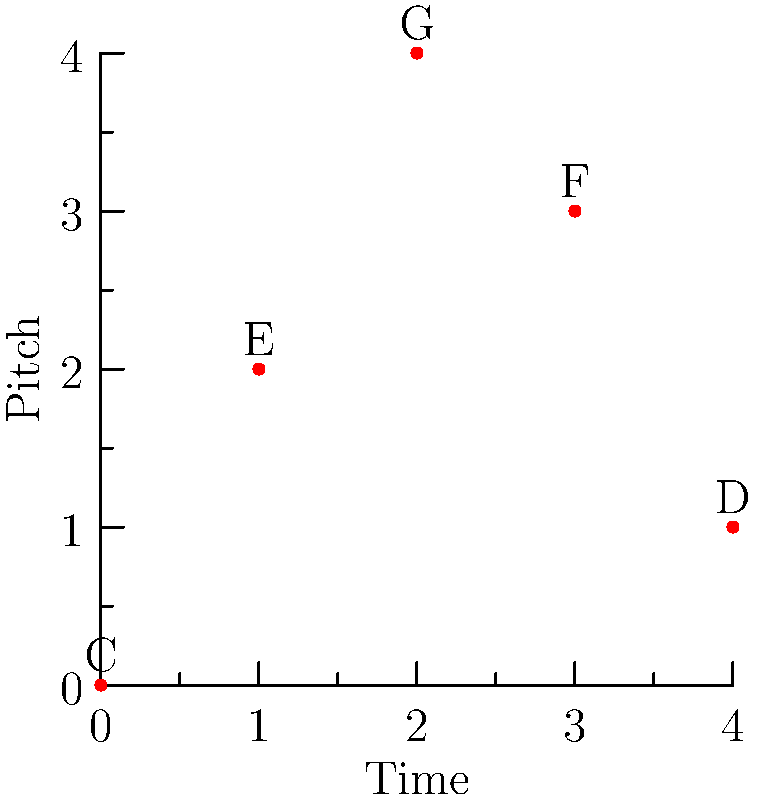As a singer-songwriter, you've composed a melody using the notes C, E, G, F, and D in that order. How many unique melodies can be created by rearranging these notes, assuming each note is used exactly once? To solve this problem, we need to understand the concept of permutations in group theory:

1. We have 5 distinct notes in our melody: C, E, G, F, and D.
2. Each note is used exactly once, and we want to find all possible arrangements.
3. This scenario is a perfect example of a permutation, where the order matters.
4. The number of permutations of n distinct objects is given by n!.
5. In this case, n = 5 (the number of notes in our melody).
6. Therefore, the number of unique melodies is 5!.
7. Calculate 5!:
   5! = 5 × 4 × 3 × 2 × 1 = 120

Thus, there are 120 unique melodies that can be created by rearranging these five notes.

This concept is fundamental in music theory and composition, as it demonstrates the vast possibilities available even with a limited set of notes, showcasing the creative potential in songwriting.
Answer: 120 